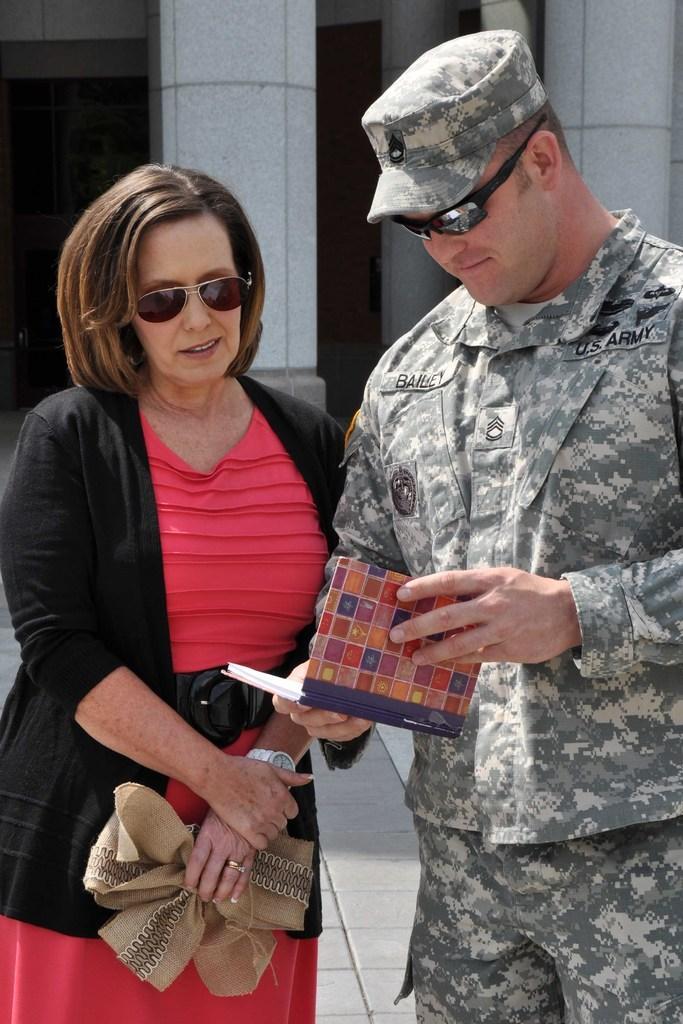How would you summarize this image in a sentence or two? This man wore goggles, army dress and holding a book. This woman wore a jacket and goggles. Background there are pillars.   